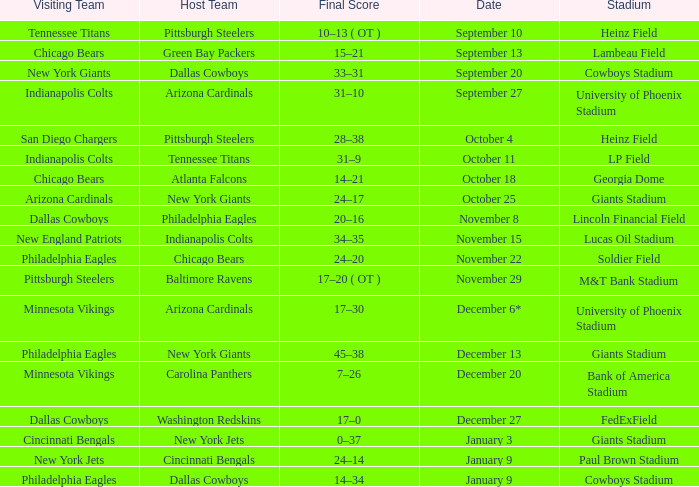Tell me the date for pittsburgh steelers November 29. 